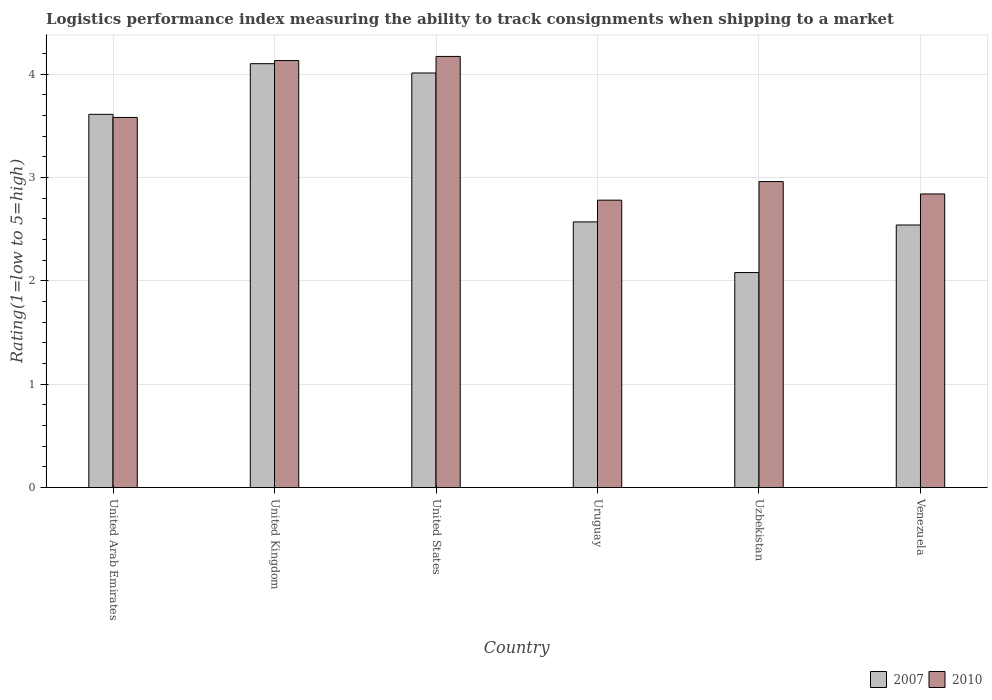How many different coloured bars are there?
Offer a terse response. 2. How many groups of bars are there?
Ensure brevity in your answer.  6. Are the number of bars per tick equal to the number of legend labels?
Keep it short and to the point. Yes. Are the number of bars on each tick of the X-axis equal?
Provide a succinct answer. Yes. How many bars are there on the 5th tick from the left?
Offer a terse response. 2. How many bars are there on the 5th tick from the right?
Ensure brevity in your answer.  2. What is the label of the 6th group of bars from the left?
Provide a succinct answer. Venezuela. In how many cases, is the number of bars for a given country not equal to the number of legend labels?
Keep it short and to the point. 0. What is the Logistic performance index in 2007 in Venezuela?
Your response must be concise. 2.54. Across all countries, what is the minimum Logistic performance index in 2010?
Provide a succinct answer. 2.78. In which country was the Logistic performance index in 2010 maximum?
Offer a terse response. United States. In which country was the Logistic performance index in 2010 minimum?
Offer a terse response. Uruguay. What is the total Logistic performance index in 2007 in the graph?
Provide a short and direct response. 18.91. What is the difference between the Logistic performance index in 2010 in United Kingdom and that in Venezuela?
Make the answer very short. 1.29. What is the difference between the Logistic performance index in 2010 in Venezuela and the Logistic performance index in 2007 in Uruguay?
Keep it short and to the point. 0.27. What is the average Logistic performance index in 2010 per country?
Offer a very short reply. 3.41. What is the difference between the Logistic performance index of/in 2007 and Logistic performance index of/in 2010 in United States?
Offer a terse response. -0.16. In how many countries, is the Logistic performance index in 2010 greater than 2.2?
Give a very brief answer. 6. What is the ratio of the Logistic performance index in 2007 in United Kingdom to that in Uruguay?
Ensure brevity in your answer.  1.6. What is the difference between the highest and the second highest Logistic performance index in 2010?
Make the answer very short. -0.59. What is the difference between the highest and the lowest Logistic performance index in 2007?
Your answer should be compact. 2.02. In how many countries, is the Logistic performance index in 2010 greater than the average Logistic performance index in 2010 taken over all countries?
Make the answer very short. 3. Is the sum of the Logistic performance index in 2007 in United Arab Emirates and Venezuela greater than the maximum Logistic performance index in 2010 across all countries?
Keep it short and to the point. Yes. What does the 1st bar from the left in Uruguay represents?
Provide a short and direct response. 2007. Are all the bars in the graph horizontal?
Make the answer very short. No. Are the values on the major ticks of Y-axis written in scientific E-notation?
Your response must be concise. No. Where does the legend appear in the graph?
Ensure brevity in your answer.  Bottom right. How are the legend labels stacked?
Give a very brief answer. Horizontal. What is the title of the graph?
Offer a terse response. Logistics performance index measuring the ability to track consignments when shipping to a market. Does "1962" appear as one of the legend labels in the graph?
Offer a very short reply. No. What is the label or title of the X-axis?
Ensure brevity in your answer.  Country. What is the label or title of the Y-axis?
Your response must be concise. Rating(1=low to 5=high). What is the Rating(1=low to 5=high) in 2007 in United Arab Emirates?
Give a very brief answer. 3.61. What is the Rating(1=low to 5=high) of 2010 in United Arab Emirates?
Keep it short and to the point. 3.58. What is the Rating(1=low to 5=high) in 2007 in United Kingdom?
Offer a very short reply. 4.1. What is the Rating(1=low to 5=high) of 2010 in United Kingdom?
Your answer should be compact. 4.13. What is the Rating(1=low to 5=high) of 2007 in United States?
Give a very brief answer. 4.01. What is the Rating(1=low to 5=high) in 2010 in United States?
Give a very brief answer. 4.17. What is the Rating(1=low to 5=high) of 2007 in Uruguay?
Keep it short and to the point. 2.57. What is the Rating(1=low to 5=high) in 2010 in Uruguay?
Your answer should be very brief. 2.78. What is the Rating(1=low to 5=high) of 2007 in Uzbekistan?
Offer a very short reply. 2.08. What is the Rating(1=low to 5=high) in 2010 in Uzbekistan?
Keep it short and to the point. 2.96. What is the Rating(1=low to 5=high) in 2007 in Venezuela?
Your answer should be very brief. 2.54. What is the Rating(1=low to 5=high) in 2010 in Venezuela?
Provide a succinct answer. 2.84. Across all countries, what is the maximum Rating(1=low to 5=high) in 2010?
Offer a very short reply. 4.17. Across all countries, what is the minimum Rating(1=low to 5=high) in 2007?
Ensure brevity in your answer.  2.08. Across all countries, what is the minimum Rating(1=low to 5=high) in 2010?
Offer a very short reply. 2.78. What is the total Rating(1=low to 5=high) in 2007 in the graph?
Your response must be concise. 18.91. What is the total Rating(1=low to 5=high) of 2010 in the graph?
Your answer should be compact. 20.46. What is the difference between the Rating(1=low to 5=high) in 2007 in United Arab Emirates and that in United Kingdom?
Make the answer very short. -0.49. What is the difference between the Rating(1=low to 5=high) in 2010 in United Arab Emirates and that in United Kingdom?
Make the answer very short. -0.55. What is the difference between the Rating(1=low to 5=high) in 2007 in United Arab Emirates and that in United States?
Make the answer very short. -0.4. What is the difference between the Rating(1=low to 5=high) in 2010 in United Arab Emirates and that in United States?
Keep it short and to the point. -0.59. What is the difference between the Rating(1=low to 5=high) in 2007 in United Arab Emirates and that in Uruguay?
Your answer should be compact. 1.04. What is the difference between the Rating(1=low to 5=high) of 2010 in United Arab Emirates and that in Uruguay?
Provide a succinct answer. 0.8. What is the difference between the Rating(1=low to 5=high) in 2007 in United Arab Emirates and that in Uzbekistan?
Provide a succinct answer. 1.53. What is the difference between the Rating(1=low to 5=high) in 2010 in United Arab Emirates and that in Uzbekistan?
Make the answer very short. 0.62. What is the difference between the Rating(1=low to 5=high) of 2007 in United Arab Emirates and that in Venezuela?
Give a very brief answer. 1.07. What is the difference between the Rating(1=low to 5=high) in 2010 in United Arab Emirates and that in Venezuela?
Ensure brevity in your answer.  0.74. What is the difference between the Rating(1=low to 5=high) in 2007 in United Kingdom and that in United States?
Ensure brevity in your answer.  0.09. What is the difference between the Rating(1=low to 5=high) in 2010 in United Kingdom and that in United States?
Your response must be concise. -0.04. What is the difference between the Rating(1=low to 5=high) in 2007 in United Kingdom and that in Uruguay?
Provide a short and direct response. 1.53. What is the difference between the Rating(1=low to 5=high) of 2010 in United Kingdom and that in Uruguay?
Your answer should be compact. 1.35. What is the difference between the Rating(1=low to 5=high) in 2007 in United Kingdom and that in Uzbekistan?
Ensure brevity in your answer.  2.02. What is the difference between the Rating(1=low to 5=high) in 2010 in United Kingdom and that in Uzbekistan?
Offer a terse response. 1.17. What is the difference between the Rating(1=low to 5=high) in 2007 in United Kingdom and that in Venezuela?
Keep it short and to the point. 1.56. What is the difference between the Rating(1=low to 5=high) of 2010 in United Kingdom and that in Venezuela?
Give a very brief answer. 1.29. What is the difference between the Rating(1=low to 5=high) in 2007 in United States and that in Uruguay?
Make the answer very short. 1.44. What is the difference between the Rating(1=low to 5=high) of 2010 in United States and that in Uruguay?
Offer a very short reply. 1.39. What is the difference between the Rating(1=low to 5=high) in 2007 in United States and that in Uzbekistan?
Your response must be concise. 1.93. What is the difference between the Rating(1=low to 5=high) of 2010 in United States and that in Uzbekistan?
Make the answer very short. 1.21. What is the difference between the Rating(1=low to 5=high) in 2007 in United States and that in Venezuela?
Make the answer very short. 1.47. What is the difference between the Rating(1=low to 5=high) of 2010 in United States and that in Venezuela?
Your answer should be compact. 1.33. What is the difference between the Rating(1=low to 5=high) in 2007 in Uruguay and that in Uzbekistan?
Your answer should be very brief. 0.49. What is the difference between the Rating(1=low to 5=high) of 2010 in Uruguay and that in Uzbekistan?
Provide a succinct answer. -0.18. What is the difference between the Rating(1=low to 5=high) in 2010 in Uruguay and that in Venezuela?
Make the answer very short. -0.06. What is the difference between the Rating(1=low to 5=high) of 2007 in Uzbekistan and that in Venezuela?
Offer a terse response. -0.46. What is the difference between the Rating(1=low to 5=high) in 2010 in Uzbekistan and that in Venezuela?
Offer a terse response. 0.12. What is the difference between the Rating(1=low to 5=high) in 2007 in United Arab Emirates and the Rating(1=low to 5=high) in 2010 in United Kingdom?
Your response must be concise. -0.52. What is the difference between the Rating(1=low to 5=high) in 2007 in United Arab Emirates and the Rating(1=low to 5=high) in 2010 in United States?
Your answer should be very brief. -0.56. What is the difference between the Rating(1=low to 5=high) of 2007 in United Arab Emirates and the Rating(1=low to 5=high) of 2010 in Uruguay?
Provide a short and direct response. 0.83. What is the difference between the Rating(1=low to 5=high) of 2007 in United Arab Emirates and the Rating(1=low to 5=high) of 2010 in Uzbekistan?
Provide a short and direct response. 0.65. What is the difference between the Rating(1=low to 5=high) of 2007 in United Arab Emirates and the Rating(1=low to 5=high) of 2010 in Venezuela?
Offer a very short reply. 0.77. What is the difference between the Rating(1=low to 5=high) of 2007 in United Kingdom and the Rating(1=low to 5=high) of 2010 in United States?
Your response must be concise. -0.07. What is the difference between the Rating(1=low to 5=high) in 2007 in United Kingdom and the Rating(1=low to 5=high) in 2010 in Uruguay?
Keep it short and to the point. 1.32. What is the difference between the Rating(1=low to 5=high) of 2007 in United Kingdom and the Rating(1=low to 5=high) of 2010 in Uzbekistan?
Your answer should be compact. 1.14. What is the difference between the Rating(1=low to 5=high) in 2007 in United Kingdom and the Rating(1=low to 5=high) in 2010 in Venezuela?
Give a very brief answer. 1.26. What is the difference between the Rating(1=low to 5=high) in 2007 in United States and the Rating(1=low to 5=high) in 2010 in Uruguay?
Offer a terse response. 1.23. What is the difference between the Rating(1=low to 5=high) of 2007 in United States and the Rating(1=low to 5=high) of 2010 in Uzbekistan?
Keep it short and to the point. 1.05. What is the difference between the Rating(1=low to 5=high) of 2007 in United States and the Rating(1=low to 5=high) of 2010 in Venezuela?
Offer a terse response. 1.17. What is the difference between the Rating(1=low to 5=high) in 2007 in Uruguay and the Rating(1=low to 5=high) in 2010 in Uzbekistan?
Offer a terse response. -0.39. What is the difference between the Rating(1=low to 5=high) in 2007 in Uruguay and the Rating(1=low to 5=high) in 2010 in Venezuela?
Provide a succinct answer. -0.27. What is the difference between the Rating(1=low to 5=high) of 2007 in Uzbekistan and the Rating(1=low to 5=high) of 2010 in Venezuela?
Ensure brevity in your answer.  -0.76. What is the average Rating(1=low to 5=high) of 2007 per country?
Offer a very short reply. 3.15. What is the average Rating(1=low to 5=high) of 2010 per country?
Provide a short and direct response. 3.41. What is the difference between the Rating(1=low to 5=high) of 2007 and Rating(1=low to 5=high) of 2010 in United Kingdom?
Make the answer very short. -0.03. What is the difference between the Rating(1=low to 5=high) of 2007 and Rating(1=low to 5=high) of 2010 in United States?
Make the answer very short. -0.16. What is the difference between the Rating(1=low to 5=high) of 2007 and Rating(1=low to 5=high) of 2010 in Uruguay?
Your response must be concise. -0.21. What is the difference between the Rating(1=low to 5=high) of 2007 and Rating(1=low to 5=high) of 2010 in Uzbekistan?
Offer a terse response. -0.88. What is the difference between the Rating(1=low to 5=high) of 2007 and Rating(1=low to 5=high) of 2010 in Venezuela?
Offer a terse response. -0.3. What is the ratio of the Rating(1=low to 5=high) in 2007 in United Arab Emirates to that in United Kingdom?
Your answer should be very brief. 0.88. What is the ratio of the Rating(1=low to 5=high) of 2010 in United Arab Emirates to that in United Kingdom?
Provide a succinct answer. 0.87. What is the ratio of the Rating(1=low to 5=high) of 2007 in United Arab Emirates to that in United States?
Offer a very short reply. 0.9. What is the ratio of the Rating(1=low to 5=high) in 2010 in United Arab Emirates to that in United States?
Provide a succinct answer. 0.86. What is the ratio of the Rating(1=low to 5=high) in 2007 in United Arab Emirates to that in Uruguay?
Your answer should be compact. 1.4. What is the ratio of the Rating(1=low to 5=high) in 2010 in United Arab Emirates to that in Uruguay?
Provide a short and direct response. 1.29. What is the ratio of the Rating(1=low to 5=high) of 2007 in United Arab Emirates to that in Uzbekistan?
Give a very brief answer. 1.74. What is the ratio of the Rating(1=low to 5=high) of 2010 in United Arab Emirates to that in Uzbekistan?
Give a very brief answer. 1.21. What is the ratio of the Rating(1=low to 5=high) of 2007 in United Arab Emirates to that in Venezuela?
Provide a succinct answer. 1.42. What is the ratio of the Rating(1=low to 5=high) of 2010 in United Arab Emirates to that in Venezuela?
Provide a short and direct response. 1.26. What is the ratio of the Rating(1=low to 5=high) of 2007 in United Kingdom to that in United States?
Keep it short and to the point. 1.02. What is the ratio of the Rating(1=low to 5=high) in 2007 in United Kingdom to that in Uruguay?
Your response must be concise. 1.6. What is the ratio of the Rating(1=low to 5=high) in 2010 in United Kingdom to that in Uruguay?
Provide a succinct answer. 1.49. What is the ratio of the Rating(1=low to 5=high) of 2007 in United Kingdom to that in Uzbekistan?
Provide a succinct answer. 1.97. What is the ratio of the Rating(1=low to 5=high) in 2010 in United Kingdom to that in Uzbekistan?
Provide a succinct answer. 1.4. What is the ratio of the Rating(1=low to 5=high) of 2007 in United Kingdom to that in Venezuela?
Provide a short and direct response. 1.61. What is the ratio of the Rating(1=low to 5=high) in 2010 in United Kingdom to that in Venezuela?
Give a very brief answer. 1.45. What is the ratio of the Rating(1=low to 5=high) of 2007 in United States to that in Uruguay?
Provide a succinct answer. 1.56. What is the ratio of the Rating(1=low to 5=high) in 2007 in United States to that in Uzbekistan?
Ensure brevity in your answer.  1.93. What is the ratio of the Rating(1=low to 5=high) of 2010 in United States to that in Uzbekistan?
Offer a terse response. 1.41. What is the ratio of the Rating(1=low to 5=high) in 2007 in United States to that in Venezuela?
Your answer should be compact. 1.58. What is the ratio of the Rating(1=low to 5=high) of 2010 in United States to that in Venezuela?
Your answer should be very brief. 1.47. What is the ratio of the Rating(1=low to 5=high) of 2007 in Uruguay to that in Uzbekistan?
Give a very brief answer. 1.24. What is the ratio of the Rating(1=low to 5=high) in 2010 in Uruguay to that in Uzbekistan?
Provide a succinct answer. 0.94. What is the ratio of the Rating(1=low to 5=high) of 2007 in Uruguay to that in Venezuela?
Make the answer very short. 1.01. What is the ratio of the Rating(1=low to 5=high) of 2010 in Uruguay to that in Venezuela?
Make the answer very short. 0.98. What is the ratio of the Rating(1=low to 5=high) in 2007 in Uzbekistan to that in Venezuela?
Provide a succinct answer. 0.82. What is the ratio of the Rating(1=low to 5=high) of 2010 in Uzbekistan to that in Venezuela?
Make the answer very short. 1.04. What is the difference between the highest and the second highest Rating(1=low to 5=high) in 2007?
Provide a succinct answer. 0.09. What is the difference between the highest and the second highest Rating(1=low to 5=high) of 2010?
Keep it short and to the point. 0.04. What is the difference between the highest and the lowest Rating(1=low to 5=high) of 2007?
Provide a short and direct response. 2.02. What is the difference between the highest and the lowest Rating(1=low to 5=high) of 2010?
Keep it short and to the point. 1.39. 